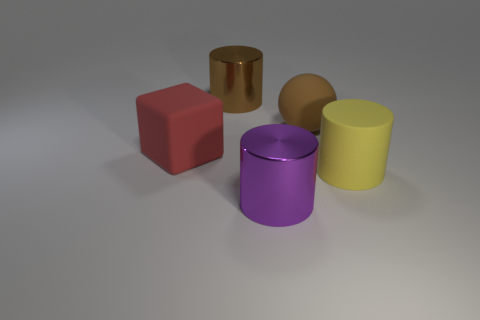Subtract all green cubes. Subtract all red cylinders. How many cubes are left? 1 Add 3 red cubes. How many objects exist? 8 Subtract all balls. How many objects are left? 4 Add 2 brown metal cylinders. How many brown metal cylinders exist? 3 Subtract 0 red spheres. How many objects are left? 5 Subtract all large brown metal things. Subtract all big red objects. How many objects are left? 3 Add 2 red things. How many red things are left? 3 